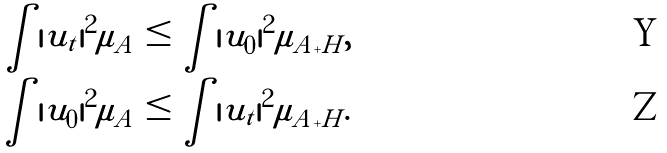<formula> <loc_0><loc_0><loc_500><loc_500>\int | u _ { t } | ^ { 2 } \mu _ { A } & \leq \int | u _ { 0 } | ^ { 2 } \mu _ { A + H } , \\ \int | u _ { 0 } | ^ { 2 } \mu _ { A } & \leq \int | u _ { t } | ^ { 2 } \mu _ { A + H } .</formula> 